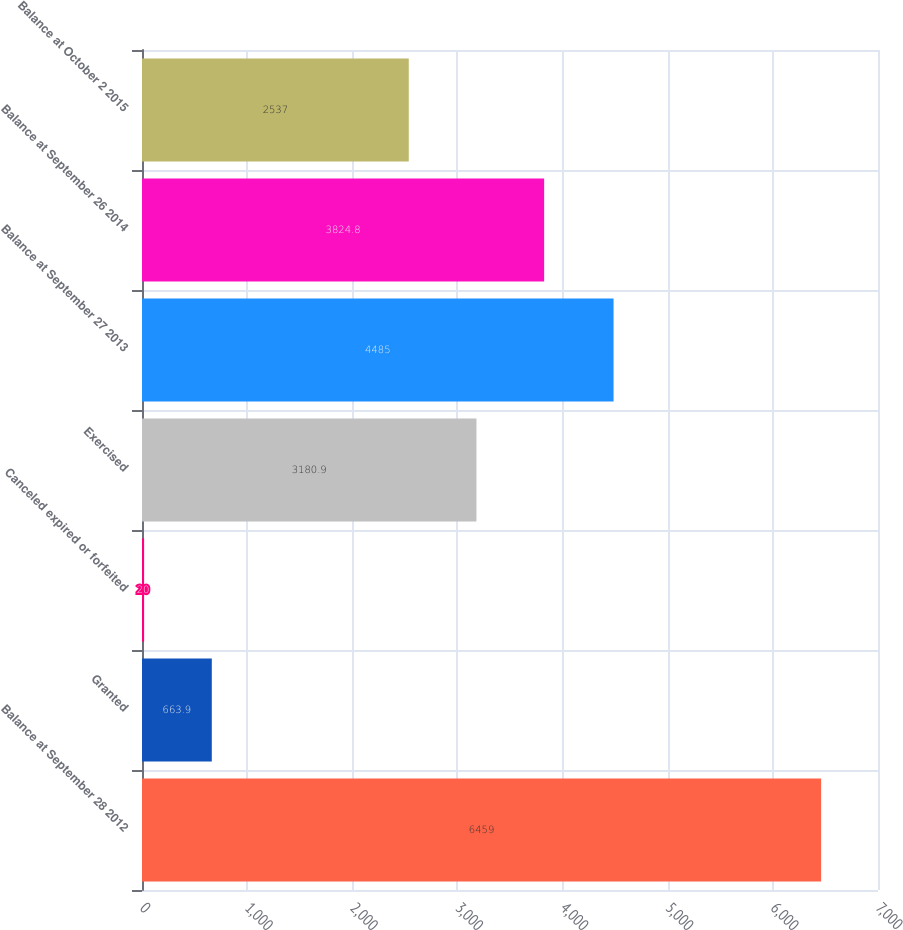Convert chart to OTSL. <chart><loc_0><loc_0><loc_500><loc_500><bar_chart><fcel>Balance at September 28 2012<fcel>Granted<fcel>Canceled expired or forfeited<fcel>Exercised<fcel>Balance at September 27 2013<fcel>Balance at September 26 2014<fcel>Balance at October 2 2015<nl><fcel>6459<fcel>663.9<fcel>20<fcel>3180.9<fcel>4485<fcel>3824.8<fcel>2537<nl></chart> 